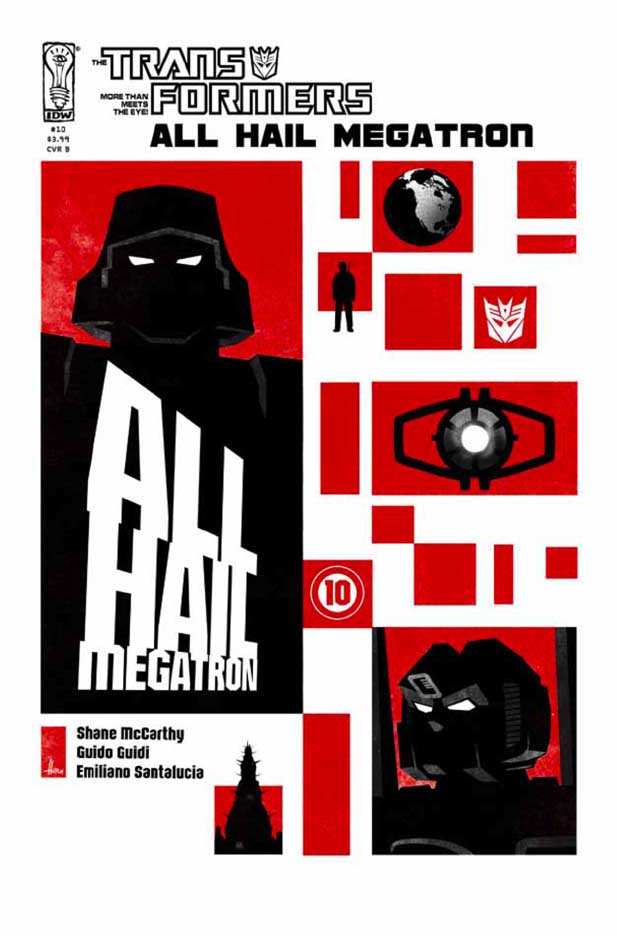Imagine the cover is animated. Describe a short animation sequence fitting this cover. In an animated sequence of this cover, the frame might first be dark and silent. Slowly, a deep red light would start to fill the screen as the silhouette of Megatron becomes illuminated, his eyes beginning to glow intensely. The 'ALL HAIL MEGATRON' text could dramatically appear, letter by letter, with a metallic clanging sound. The Decepticon insignia would then emerge with a sharp gleam, as mechanical sounds and distant explosions begin to grow louder, immersing the viewer in the impending sense of battle and dominance that the scene conveys. 